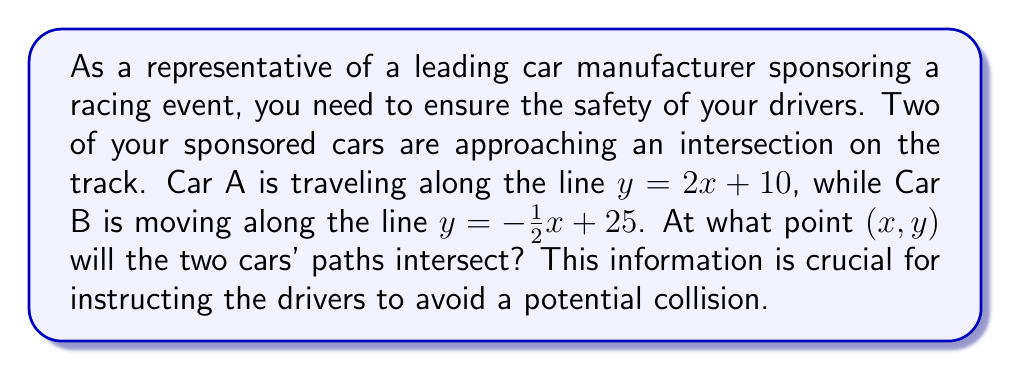Help me with this question. To find the intersection point of the two cars' paths, we need to solve the system of equations representing their trajectories:

$$\begin{cases}
y = 2x + 10 \quad \text{(Car A)}\\
y = -\frac{1}{2}x + 25 \quad \text{(Car B)}
\end{cases}$$

Let's solve this step-by-step:

1) At the intersection point, the y-coordinates will be equal. So we can set the right sides of the equations equal to each other:

   $2x + 10 = -\frac{1}{2}x + 25$

2) Now, let's solve for x:
   
   $2x + \frac{1}{2}x = 25 - 10$
   $\frac{5}{2}x = 15$
   $x = 15 \cdot \frac{2}{5} = 6$

3) Now that we know the x-coordinate of the intersection point, we can substitute this back into either of the original equations to find the y-coordinate. Let's use Car A's equation:

   $y = 2(6) + 10 = 12 + 10 = 22$

Therefore, the paths of the two cars will intersect at the point (6, 22).

[asy]
import graph;
size(200);
xaxis("x");
yaxis("y");

real f(real x) {return 2x + 10;}
real g(real x) {return -0.5x + 25;}

draw(graph(f,-5,10),blue);
draw(graph(g,-5,10),red);

dot((6,22),green);
label("(6, 22)",(6,22),NE);

label("Car A",(-3,f(-3)),NW,blue);
label("Car B",(8,g(8)),SE,red);
[/asy]

This visualization shows the paths of Car A (blue line) and Car B (red line), with their intersection point marked in green.
Answer: The two cars' paths will intersect at the point (6, 22). 